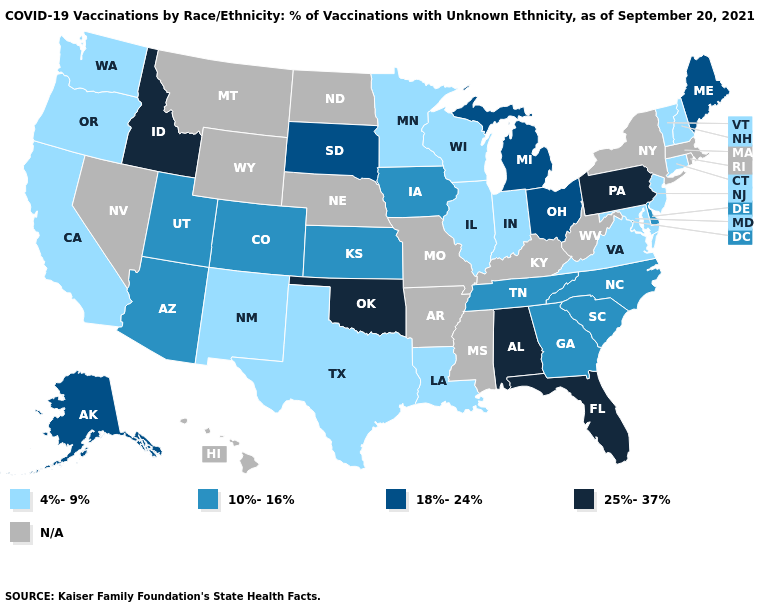How many symbols are there in the legend?
Keep it brief. 5. Does the map have missing data?
Concise answer only. Yes. What is the highest value in states that border North Dakota?
Answer briefly. 18%-24%. Which states have the lowest value in the South?
Be succinct. Louisiana, Maryland, Texas, Virginia. What is the highest value in states that border Delaware?
Be succinct. 25%-37%. Does the map have missing data?
Answer briefly. Yes. Among the states that border Tennessee , which have the highest value?
Keep it brief. Alabama. What is the lowest value in the South?
Write a very short answer. 4%-9%. What is the value of Mississippi?
Keep it brief. N/A. What is the lowest value in states that border Iowa?
Keep it brief. 4%-9%. What is the value of Colorado?
Keep it brief. 10%-16%. Which states have the highest value in the USA?
Concise answer only. Alabama, Florida, Idaho, Oklahoma, Pennsylvania. What is the value of Wisconsin?
Keep it brief. 4%-9%. What is the value of Nebraska?
Short answer required. N/A. What is the lowest value in states that border Oregon?
Be succinct. 4%-9%. 